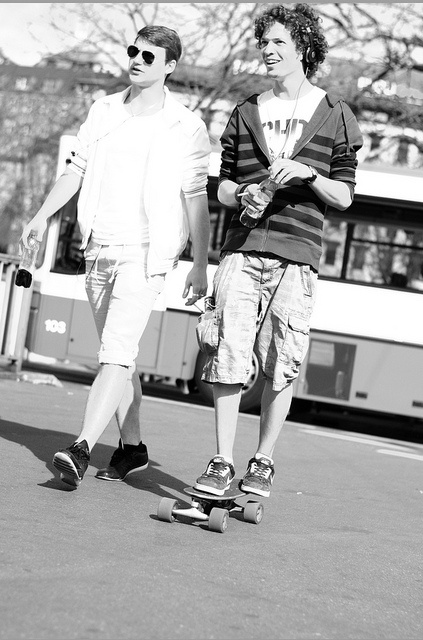Describe the objects in this image and their specific colors. I can see people in darkgray, lightgray, black, and gray tones, people in darkgray, white, gray, and black tones, bus in darkgray, white, gray, and black tones, skateboard in darkgray, black, gray, and lightgray tones, and bottle in darkgray, gray, black, and lightgray tones in this image. 